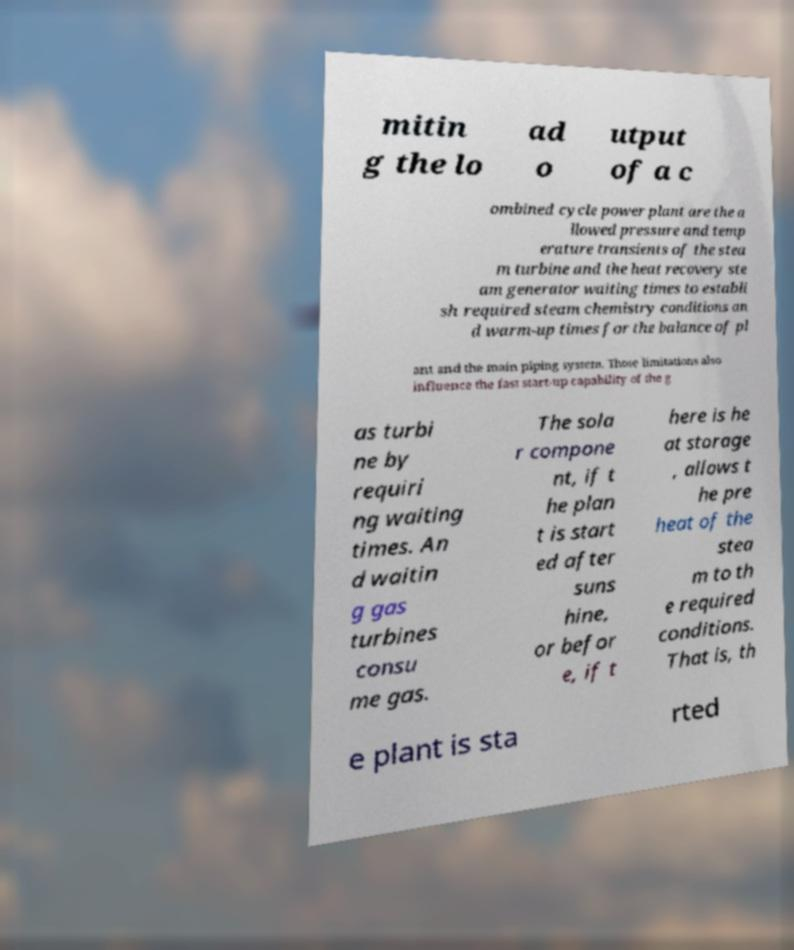Could you assist in decoding the text presented in this image and type it out clearly? mitin g the lo ad o utput of a c ombined cycle power plant are the a llowed pressure and temp erature transients of the stea m turbine and the heat recovery ste am generator waiting times to establi sh required steam chemistry conditions an d warm-up times for the balance of pl ant and the main piping system. Those limitations also influence the fast start-up capability of the g as turbi ne by requiri ng waiting times. An d waitin g gas turbines consu me gas. The sola r compone nt, if t he plan t is start ed after suns hine, or befor e, if t here is he at storage , allows t he pre heat of the stea m to th e required conditions. That is, th e plant is sta rted 